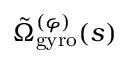<formula> <loc_0><loc_0><loc_500><loc_500>\tilde { \Omega } _ { g y r o } ^ { ( \varphi ) } ( s )</formula> 